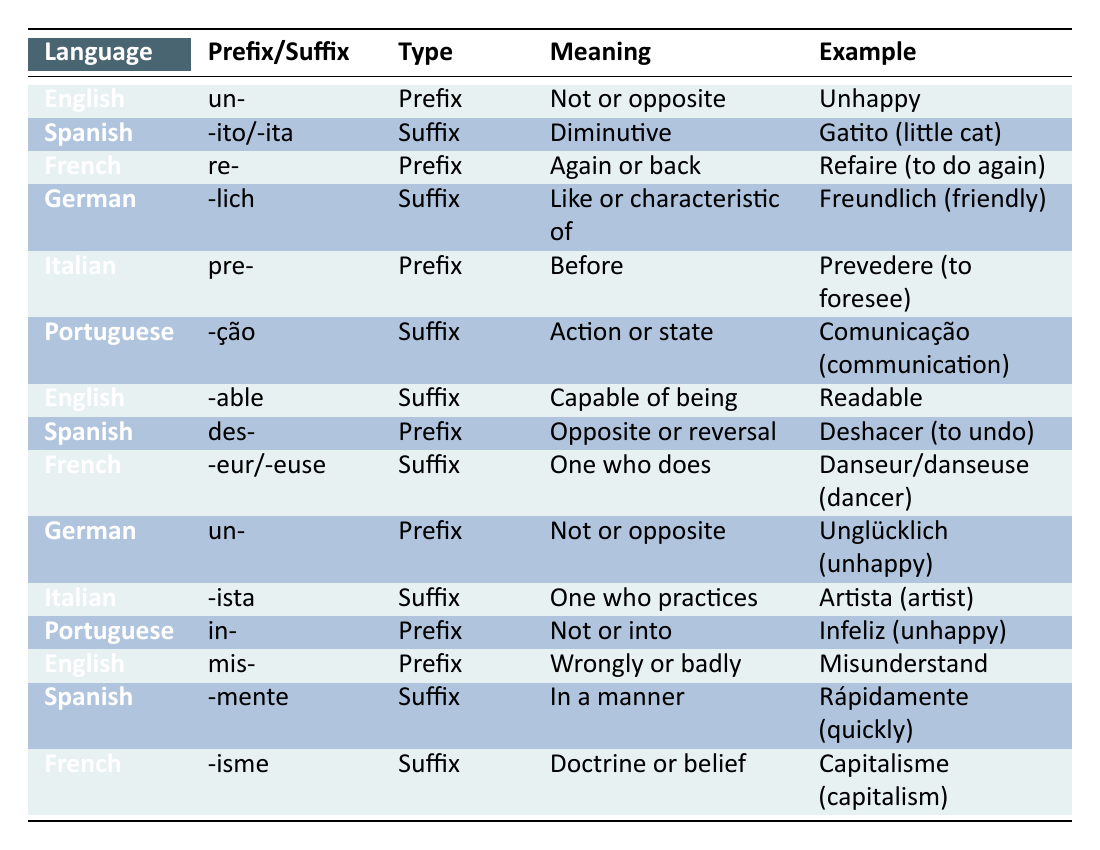What is the meaning of the prefix "re-" in French? The prefix "re-" in French is defined as "Again or back." This can be confirmed by looking at the row that contains "re-" under the French language.
Answer: Again or back Which suffix is used in Spanish to indicate a diminutive form? The suffix used in Spanish to indicate a diminutive form is "-ito/-ita," as shown in the second row labeled under Spanish.
Answer: -ito/-ita Are there any prefixes in the table that mean "not or opposite"? Yes, there are two prefixes in the table that mean "not or opposite": "un-" in English and "un-" in German. Both are found in their respective rows.
Answer: Yes What is the total number of different languages being represented in the table? The table lists prefixes and suffixes from five different languages: English, Spanish, French, German, Italian, and Portuguese. Counting these, we find six unique languages represented.
Answer: Six Which language has a suffix that corresponds to "action or state"? The language that has a suffix corresponding to "action or state" is Portuguese with the suffix "-ção," as detailed in the row for Portuguese.
Answer: Portuguese What is the average number of characters in the prefixes or suffixes listed in the table? To find the average, count the total number of characters in each prefix and suffix, which can be summarized as follows: "un-" (2), "-ito/-ita" (7), "re-" (2), "-lich" (5), "pre-" (3), "-ção" (4), "-able" (5), "des-" (3), "-eur/-euse" (7), "un-" (2), "-ista" (5), "in-" (2), "mis-" (3), "-mente" (7), "-isme" (5). The total character count is 60 and there are 14 entries, thus the average is 60/14 ≈ 4.29.
Answer: Approximately 4.29 Do any of the words in the examples include a term for "friendly"? Yes, the German word "freundlich" translates to "friendly," which appears in the row marked for the German suffix "-lich."
Answer: Yes What suffixes are associated with indicating the profession of a person? The suffixes that indicate the profession of a person are "-eur/-euse" in French, which refers to "One who does," and "-ista" in Italian, meaning "One who practices." This can be seen in the corresponding rows for each language.
Answer: -eur/-euse and -ista 